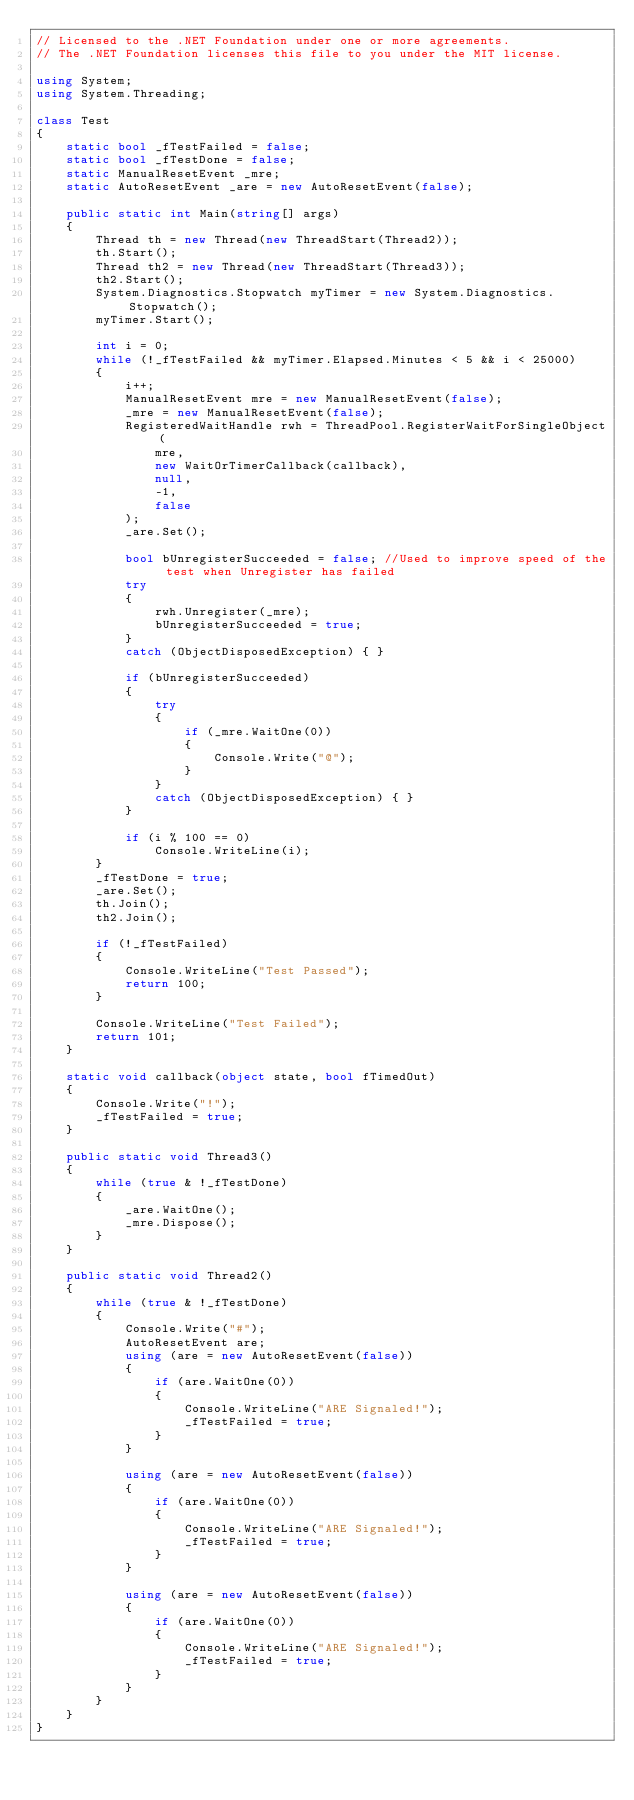<code> <loc_0><loc_0><loc_500><loc_500><_C#_>// Licensed to the .NET Foundation under one or more agreements.
// The .NET Foundation licenses this file to you under the MIT license.

using System;
using System.Threading;

class Test
{
    static bool _fTestFailed = false;
    static bool _fTestDone = false;
    static ManualResetEvent _mre;
    static AutoResetEvent _are = new AutoResetEvent(false);

    public static int Main(string[] args)
    {
        Thread th = new Thread(new ThreadStart(Thread2));
        th.Start();
        Thread th2 = new Thread(new ThreadStart(Thread3));
        th2.Start();
        System.Diagnostics.Stopwatch myTimer = new System.Diagnostics.Stopwatch();
        myTimer.Start();

        int i = 0;
        while (!_fTestFailed && myTimer.Elapsed.Minutes < 5 && i < 25000)
        {
            i++;
            ManualResetEvent mre = new ManualResetEvent(false);
            _mre = new ManualResetEvent(false);
            RegisteredWaitHandle rwh = ThreadPool.RegisterWaitForSingleObject(
                mre,
                new WaitOrTimerCallback(callback),
                null,
                -1,
                false
            );
            _are.Set();

            bool bUnregisterSucceeded = false; //Used to improve speed of the test when Unregister has failed
            try
            {
                rwh.Unregister(_mre);
                bUnregisterSucceeded = true;
            }
            catch (ObjectDisposedException) { }

            if (bUnregisterSucceeded)
            {
                try
                {
                    if (_mre.WaitOne(0))
                    {
                        Console.Write("@");
                    }
                }
                catch (ObjectDisposedException) { }
            }

            if (i % 100 == 0)
                Console.WriteLine(i);
        }
        _fTestDone = true;
        _are.Set();
        th.Join();
        th2.Join();

        if (!_fTestFailed)
        {
            Console.WriteLine("Test Passed");
            return 100;
        }

        Console.WriteLine("Test Failed");
        return 101;
    }

    static void callback(object state, bool fTimedOut)
    {
        Console.Write("!");
        _fTestFailed = true;
    }

    public static void Thread3()
    {
        while (true & !_fTestDone)
        {
            _are.WaitOne();
            _mre.Dispose();
        }
    }

    public static void Thread2()
    {
        while (true & !_fTestDone)
        {
            Console.Write("#");
            AutoResetEvent are;
            using (are = new AutoResetEvent(false))
            {
                if (are.WaitOne(0))
                {
                    Console.WriteLine("ARE Signaled!");
                    _fTestFailed = true;
                }
            }

            using (are = new AutoResetEvent(false))
            {
                if (are.WaitOne(0))
                {
                    Console.WriteLine("ARE Signaled!");
                    _fTestFailed = true;
                }
            }

            using (are = new AutoResetEvent(false))
            {
                if (are.WaitOne(0))
                {
                    Console.WriteLine("ARE Signaled!");
                    _fTestFailed = true;
                }
            }
        }
    }
}
</code> 